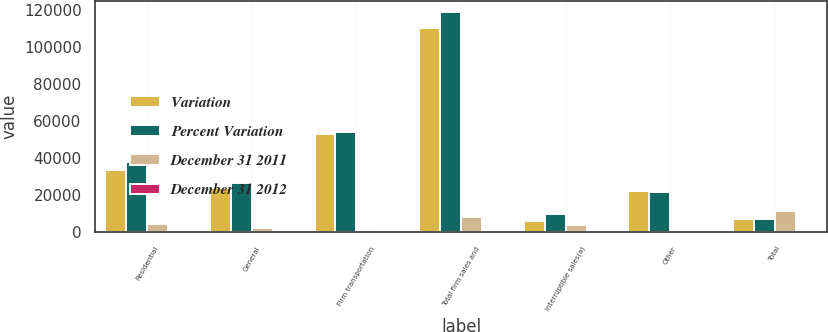<chart> <loc_0><loc_0><loc_500><loc_500><stacked_bar_chart><ecel><fcel>Residential<fcel>General<fcel>Firm transportation<fcel>Total firm sales and<fcel>Interruptible sales(a)<fcel>Other<fcel>Total<nl><fcel>Variation<fcel>33457<fcel>24138<fcel>52860<fcel>110455<fcel>5961<fcel>22259<fcel>7246.5<nl><fcel>Percent Variation<fcel>38160<fcel>26536<fcel>54291<fcel>118987<fcel>10035<fcel>21956<fcel>7246.5<nl><fcel>December 31 2011<fcel>4703<fcel>2398<fcel>1431<fcel>8532<fcel>4074<fcel>303<fcel>11531<nl><fcel>December 31 2012<fcel>12.3<fcel>9<fcel>2.6<fcel>7.2<fcel>40.6<fcel>1.4<fcel>4.4<nl></chart> 